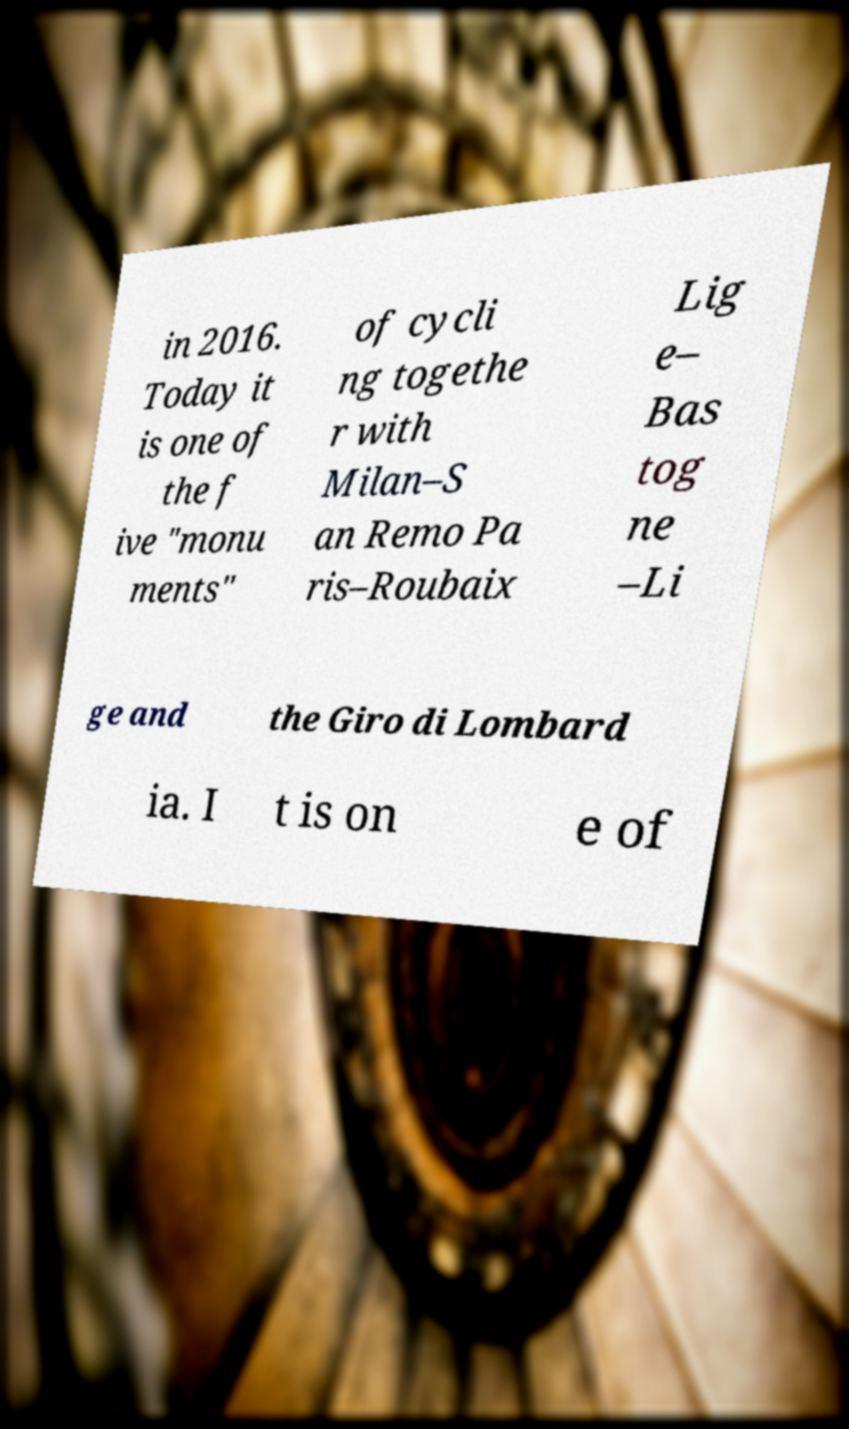What messages or text are displayed in this image? I need them in a readable, typed format. in 2016. Today it is one of the f ive "monu ments" of cycli ng togethe r with Milan–S an Remo Pa ris–Roubaix Lig e– Bas tog ne –Li ge and the Giro di Lombard ia. I t is on e of 